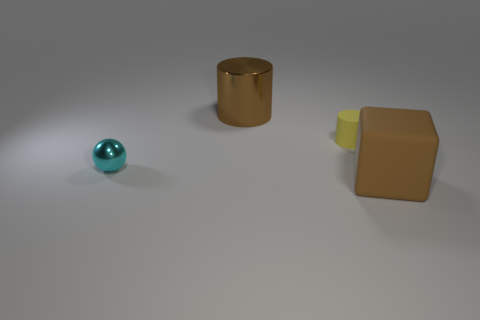How big is the thing that is both on the right side of the big cylinder and to the left of the big rubber object?
Your answer should be very brief. Small. Is there any other thing that is the same color as the large rubber object?
Ensure brevity in your answer.  Yes. What is the shape of the large thing that is made of the same material as the tiny yellow thing?
Your answer should be compact. Cube. Is the shape of the small cyan metallic object the same as the object that is right of the tiny matte thing?
Provide a succinct answer. No. What material is the large thing to the right of the big thing behind the tiny yellow cylinder?
Keep it short and to the point. Rubber. Is the number of large brown shiny objects right of the tiny matte object the same as the number of large red matte things?
Your answer should be compact. Yes. Is there any other thing that has the same material as the large brown cylinder?
Offer a very short reply. Yes. There is a metal thing that is to the right of the shiny ball; is it the same color as the shiny sphere that is in front of the yellow matte object?
Make the answer very short. No. How many objects are both left of the tiny yellow cylinder and in front of the big cylinder?
Offer a terse response. 1. How many other things are there of the same shape as the brown rubber thing?
Provide a short and direct response. 0. 